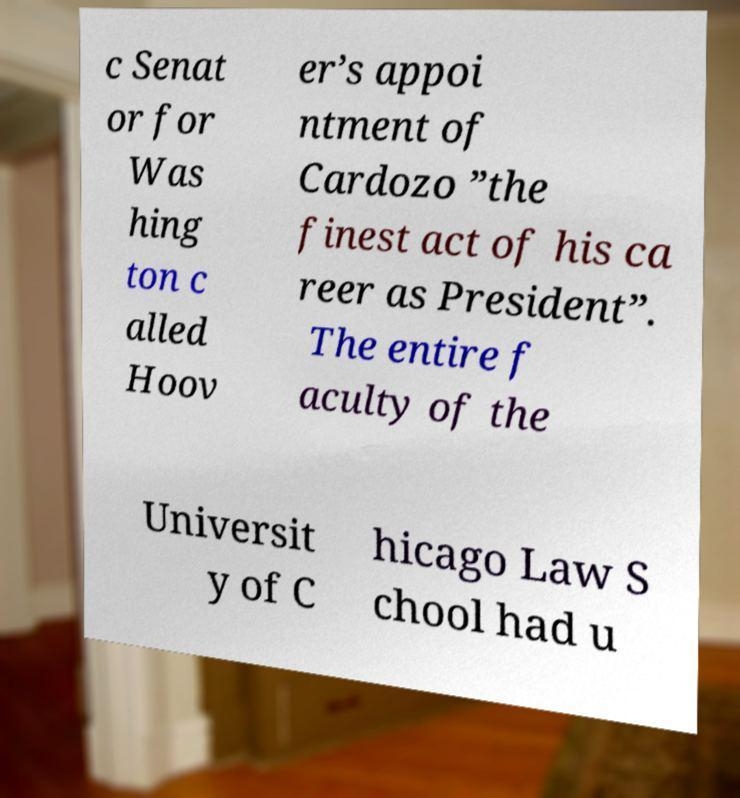Please read and relay the text visible in this image. What does it say? c Senat or for Was hing ton c alled Hoov er’s appoi ntment of Cardozo ”the finest act of his ca reer as President”. The entire f aculty of the Universit y of C hicago Law S chool had u 